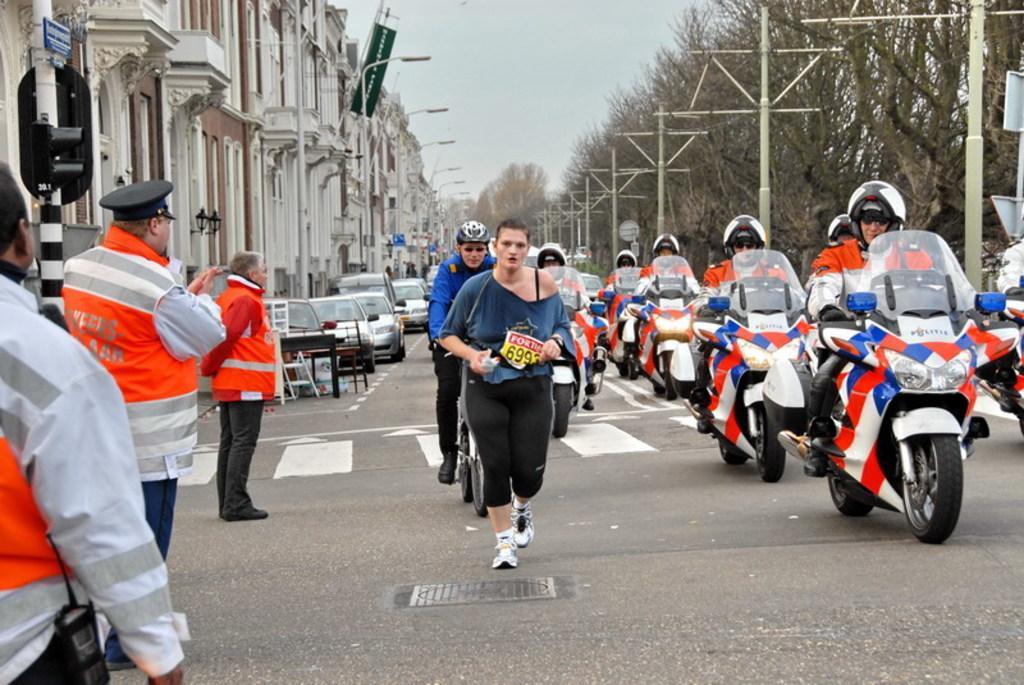Please provide a concise description of this image. In this image I can see number of people are standing and also few of them are on their bikes. In the background I can see few more vehicles and few buildings. This side I can see few moles and number of trees. 